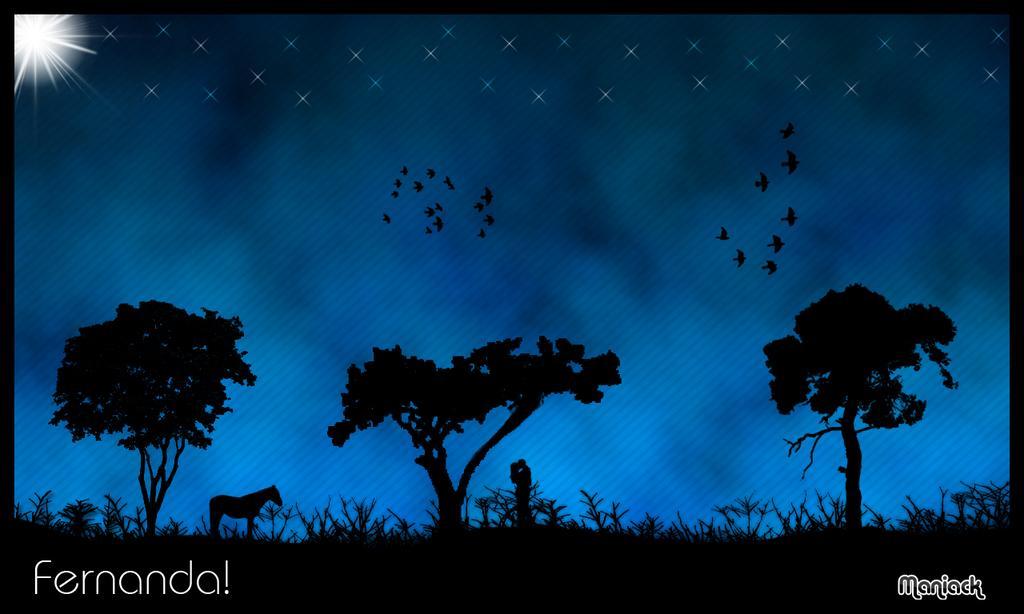Describe this image in one or two sentences. This is an animated image, there is the sky, there are stars in the sky, there are birds flying, there are trees, there are plants, there is a man standing, there is a woman standing, there is a horse, there is text towards the bottom of the image. 